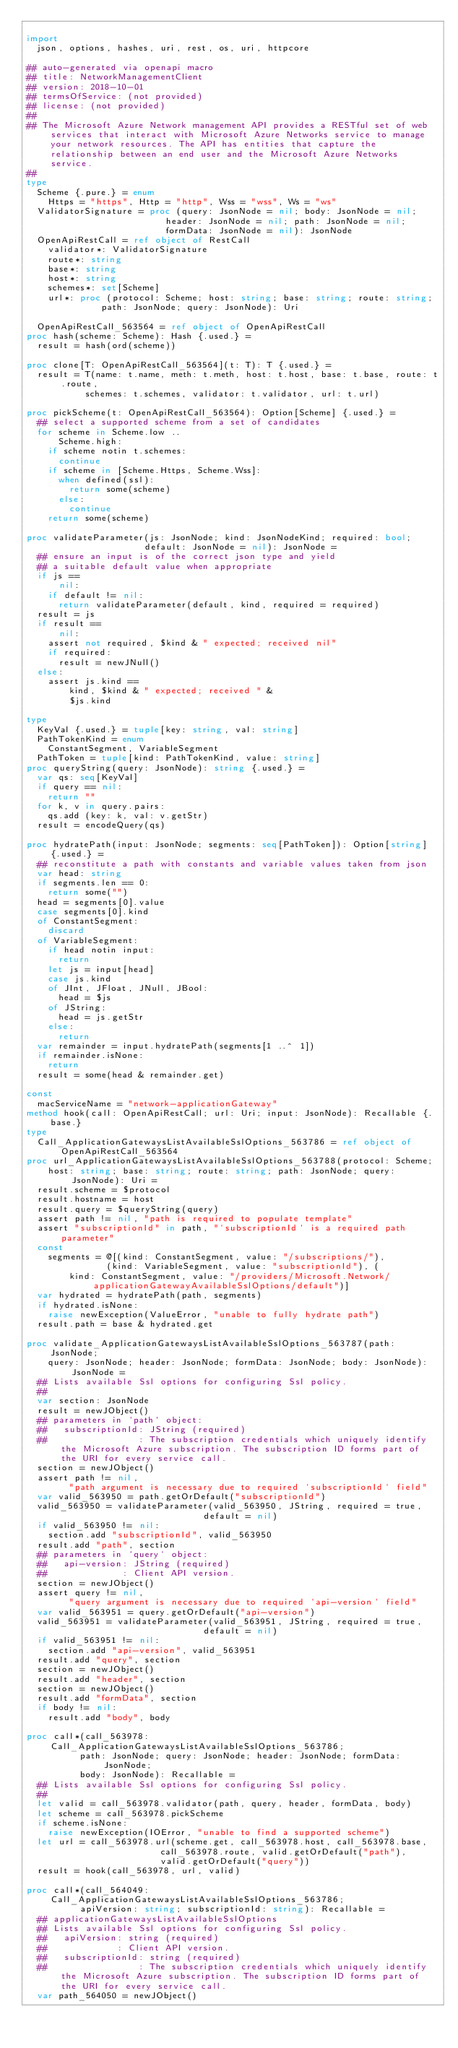<code> <loc_0><loc_0><loc_500><loc_500><_Nim_>
import
  json, options, hashes, uri, rest, os, uri, httpcore

## auto-generated via openapi macro
## title: NetworkManagementClient
## version: 2018-10-01
## termsOfService: (not provided)
## license: (not provided)
## 
## The Microsoft Azure Network management API provides a RESTful set of web services that interact with Microsoft Azure Networks service to manage your network resources. The API has entities that capture the relationship between an end user and the Microsoft Azure Networks service.
## 
type
  Scheme {.pure.} = enum
    Https = "https", Http = "http", Wss = "wss", Ws = "ws"
  ValidatorSignature = proc (query: JsonNode = nil; body: JsonNode = nil;
                          header: JsonNode = nil; path: JsonNode = nil;
                          formData: JsonNode = nil): JsonNode
  OpenApiRestCall = ref object of RestCall
    validator*: ValidatorSignature
    route*: string
    base*: string
    host*: string
    schemes*: set[Scheme]
    url*: proc (protocol: Scheme; host: string; base: string; route: string;
              path: JsonNode; query: JsonNode): Uri

  OpenApiRestCall_563564 = ref object of OpenApiRestCall
proc hash(scheme: Scheme): Hash {.used.} =
  result = hash(ord(scheme))

proc clone[T: OpenApiRestCall_563564](t: T): T {.used.} =
  result = T(name: t.name, meth: t.meth, host: t.host, base: t.base, route: t.route,
           schemes: t.schemes, validator: t.validator, url: t.url)

proc pickScheme(t: OpenApiRestCall_563564): Option[Scheme] {.used.} =
  ## select a supported scheme from a set of candidates
  for scheme in Scheme.low ..
      Scheme.high:
    if scheme notin t.schemes:
      continue
    if scheme in [Scheme.Https, Scheme.Wss]:
      when defined(ssl):
        return some(scheme)
      else:
        continue
    return some(scheme)

proc validateParameter(js: JsonNode; kind: JsonNodeKind; required: bool;
                      default: JsonNode = nil): JsonNode =
  ## ensure an input is of the correct json type and yield
  ## a suitable default value when appropriate
  if js ==
      nil:
    if default != nil:
      return validateParameter(default, kind, required = required)
  result = js
  if result ==
      nil:
    assert not required, $kind & " expected; received nil"
    if required:
      result = newJNull()
  else:
    assert js.kind ==
        kind, $kind & " expected; received " &
        $js.kind

type
  KeyVal {.used.} = tuple[key: string, val: string]
  PathTokenKind = enum
    ConstantSegment, VariableSegment
  PathToken = tuple[kind: PathTokenKind, value: string]
proc queryString(query: JsonNode): string {.used.} =
  var qs: seq[KeyVal]
  if query == nil:
    return ""
  for k, v in query.pairs:
    qs.add (key: k, val: v.getStr)
  result = encodeQuery(qs)

proc hydratePath(input: JsonNode; segments: seq[PathToken]): Option[string] {.used.} =
  ## reconstitute a path with constants and variable values taken from json
  var head: string
  if segments.len == 0:
    return some("")
  head = segments[0].value
  case segments[0].kind
  of ConstantSegment:
    discard
  of VariableSegment:
    if head notin input:
      return
    let js = input[head]
    case js.kind
    of JInt, JFloat, JNull, JBool:
      head = $js
    of JString:
      head = js.getStr
    else:
      return
  var remainder = input.hydratePath(segments[1 ..^ 1])
  if remainder.isNone:
    return
  result = some(head & remainder.get)

const
  macServiceName = "network-applicationGateway"
method hook(call: OpenApiRestCall; url: Uri; input: JsonNode): Recallable {.base.}
type
  Call_ApplicationGatewaysListAvailableSslOptions_563786 = ref object of OpenApiRestCall_563564
proc url_ApplicationGatewaysListAvailableSslOptions_563788(protocol: Scheme;
    host: string; base: string; route: string; path: JsonNode; query: JsonNode): Uri =
  result.scheme = $protocol
  result.hostname = host
  result.query = $queryString(query)
  assert path != nil, "path is required to populate template"
  assert "subscriptionId" in path, "`subscriptionId` is a required path parameter"
  const
    segments = @[(kind: ConstantSegment, value: "/subscriptions/"),
               (kind: VariableSegment, value: "subscriptionId"), (
        kind: ConstantSegment, value: "/providers/Microsoft.Network/applicationGatewayAvailableSslOptions/default")]
  var hydrated = hydratePath(path, segments)
  if hydrated.isNone:
    raise newException(ValueError, "unable to fully hydrate path")
  result.path = base & hydrated.get

proc validate_ApplicationGatewaysListAvailableSslOptions_563787(path: JsonNode;
    query: JsonNode; header: JsonNode; formData: JsonNode; body: JsonNode): JsonNode =
  ## Lists available Ssl options for configuring Ssl policy.
  ## 
  var section: JsonNode
  result = newJObject()
  ## parameters in `path` object:
  ##   subscriptionId: JString (required)
  ##                 : The subscription credentials which uniquely identify the Microsoft Azure subscription. The subscription ID forms part of the URI for every service call.
  section = newJObject()
  assert path != nil,
        "path argument is necessary due to required `subscriptionId` field"
  var valid_563950 = path.getOrDefault("subscriptionId")
  valid_563950 = validateParameter(valid_563950, JString, required = true,
                                 default = nil)
  if valid_563950 != nil:
    section.add "subscriptionId", valid_563950
  result.add "path", section
  ## parameters in `query` object:
  ##   api-version: JString (required)
  ##              : Client API version.
  section = newJObject()
  assert query != nil,
        "query argument is necessary due to required `api-version` field"
  var valid_563951 = query.getOrDefault("api-version")
  valid_563951 = validateParameter(valid_563951, JString, required = true,
                                 default = nil)
  if valid_563951 != nil:
    section.add "api-version", valid_563951
  result.add "query", section
  section = newJObject()
  result.add "header", section
  section = newJObject()
  result.add "formData", section
  if body != nil:
    result.add "body", body

proc call*(call_563978: Call_ApplicationGatewaysListAvailableSslOptions_563786;
          path: JsonNode; query: JsonNode; header: JsonNode; formData: JsonNode;
          body: JsonNode): Recallable =
  ## Lists available Ssl options for configuring Ssl policy.
  ## 
  let valid = call_563978.validator(path, query, header, formData, body)
  let scheme = call_563978.pickScheme
  if scheme.isNone:
    raise newException(IOError, "unable to find a supported scheme")
  let url = call_563978.url(scheme.get, call_563978.host, call_563978.base,
                         call_563978.route, valid.getOrDefault("path"),
                         valid.getOrDefault("query"))
  result = hook(call_563978, url, valid)

proc call*(call_564049: Call_ApplicationGatewaysListAvailableSslOptions_563786;
          apiVersion: string; subscriptionId: string): Recallable =
  ## applicationGatewaysListAvailableSslOptions
  ## Lists available Ssl options for configuring Ssl policy.
  ##   apiVersion: string (required)
  ##             : Client API version.
  ##   subscriptionId: string (required)
  ##                 : The subscription credentials which uniquely identify the Microsoft Azure subscription. The subscription ID forms part of the URI for every service call.
  var path_564050 = newJObject()</code> 